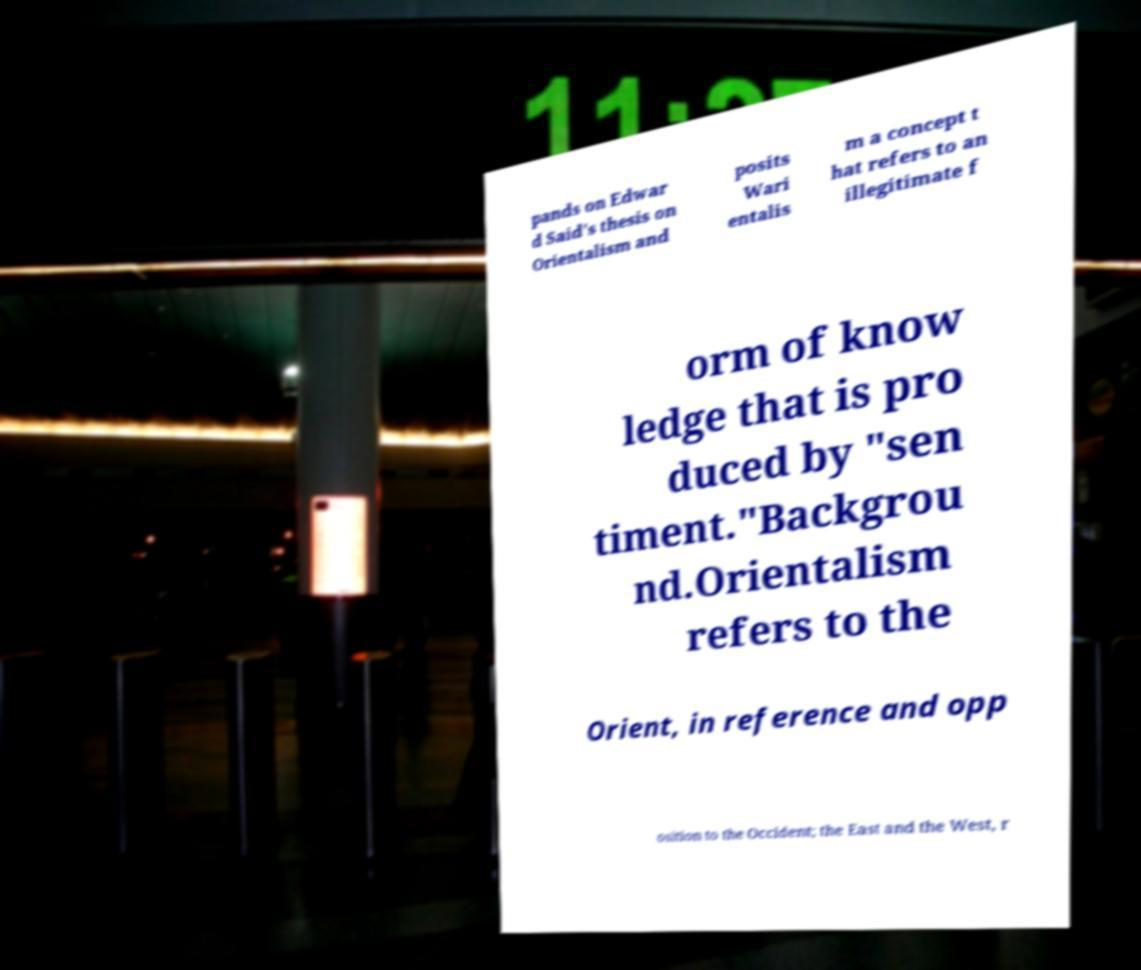For documentation purposes, I need the text within this image transcribed. Could you provide that? pands on Edwar d Said's thesis on Orientalism and posits Wari entalis m a concept t hat refers to an illegitimate f orm of know ledge that is pro duced by "sen timent."Backgrou nd.Orientalism refers to the Orient, in reference and opp osition to the Occident; the East and the West, r 